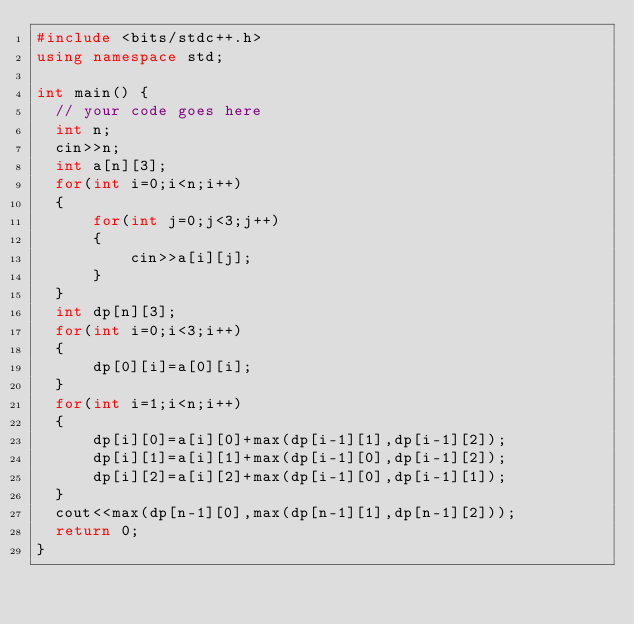<code> <loc_0><loc_0><loc_500><loc_500><_C++_>#include <bits/stdc++.h>
using namespace std;

int main() {
	// your code goes here
	int n;
	cin>>n;
	int a[n][3];
	for(int i=0;i<n;i++)
	{
	    for(int j=0;j<3;j++)
	    {
	        cin>>a[i][j];
	    }
	}
	int dp[n][3];
	for(int i=0;i<3;i++)
	{
	    dp[0][i]=a[0][i];
	}
	for(int i=1;i<n;i++)
	{
	    dp[i][0]=a[i][0]+max(dp[i-1][1],dp[i-1][2]);
	    dp[i][1]=a[i][1]+max(dp[i-1][0],dp[i-1][2]);
	    dp[i][2]=a[i][2]+max(dp[i-1][0],dp[i-1][1]);
	}
	cout<<max(dp[n-1][0],max(dp[n-1][1],dp[n-1][2]));
	return 0;
}
</code> 